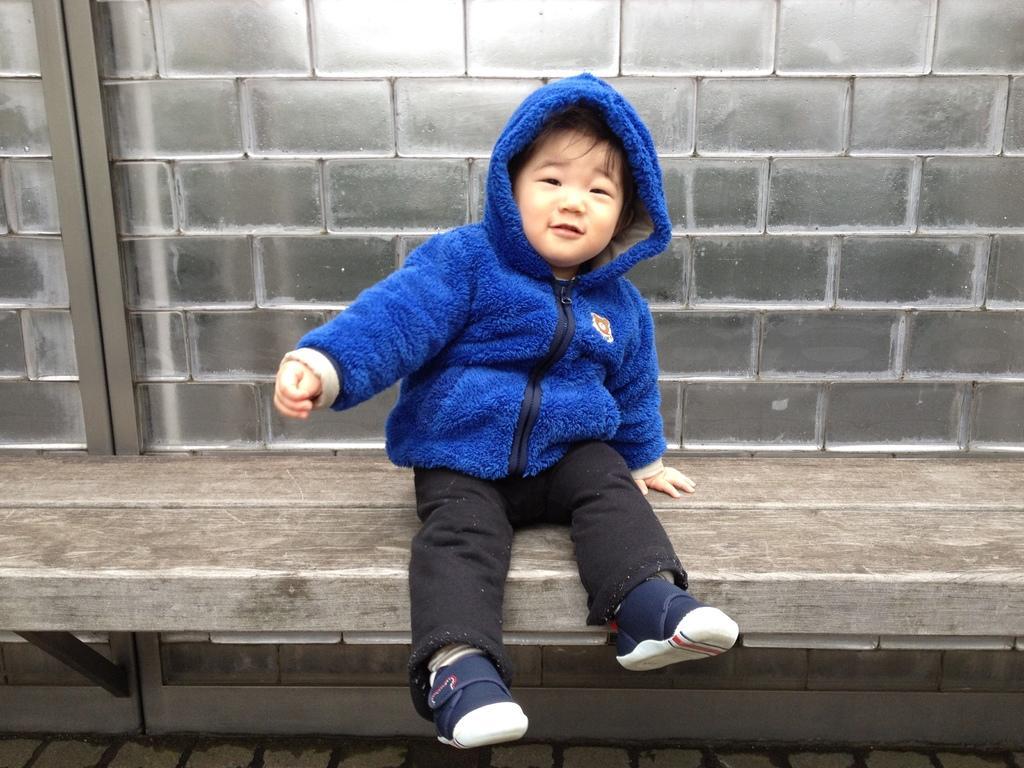Describe this image in one or two sentences. Here in this picture we can see a child wearing a sweater and sitting on a bench present over there and we can see he is smiling. 